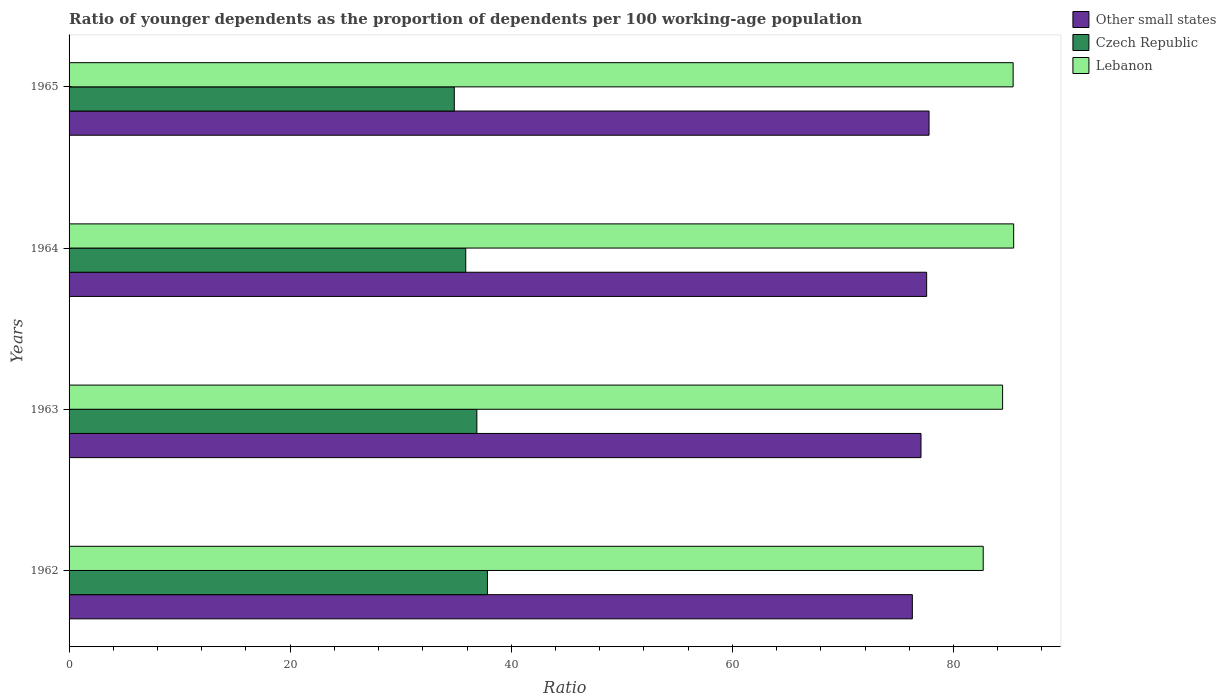Are the number of bars per tick equal to the number of legend labels?
Keep it short and to the point. Yes. How many bars are there on the 3rd tick from the bottom?
Your answer should be compact. 3. In how many cases, is the number of bars for a given year not equal to the number of legend labels?
Offer a very short reply. 0. What is the age dependency ratio(young) in Lebanon in 1965?
Provide a succinct answer. 85.39. Across all years, what is the maximum age dependency ratio(young) in Lebanon?
Provide a short and direct response. 85.44. Across all years, what is the minimum age dependency ratio(young) in Czech Republic?
Provide a short and direct response. 34.84. In which year was the age dependency ratio(young) in Other small states maximum?
Keep it short and to the point. 1965. What is the total age dependency ratio(young) in Other small states in the graph?
Ensure brevity in your answer.  308.7. What is the difference between the age dependency ratio(young) in Other small states in 1963 and that in 1964?
Ensure brevity in your answer.  -0.51. What is the difference between the age dependency ratio(young) in Czech Republic in 1962 and the age dependency ratio(young) in Other small states in 1965?
Offer a very short reply. -39.95. What is the average age dependency ratio(young) in Czech Republic per year?
Make the answer very short. 36.36. In the year 1963, what is the difference between the age dependency ratio(young) in Czech Republic and age dependency ratio(young) in Other small states?
Offer a very short reply. -40.17. What is the ratio of the age dependency ratio(young) in Czech Republic in 1962 to that in 1964?
Offer a terse response. 1.05. Is the difference between the age dependency ratio(young) in Czech Republic in 1963 and 1965 greater than the difference between the age dependency ratio(young) in Other small states in 1963 and 1965?
Your response must be concise. Yes. What is the difference between the highest and the second highest age dependency ratio(young) in Czech Republic?
Offer a terse response. 0.95. What is the difference between the highest and the lowest age dependency ratio(young) in Lebanon?
Provide a short and direct response. 2.75. Is the sum of the age dependency ratio(young) in Czech Republic in 1962 and 1964 greater than the maximum age dependency ratio(young) in Lebanon across all years?
Provide a short and direct response. No. What does the 3rd bar from the top in 1965 represents?
Provide a succinct answer. Other small states. What does the 1st bar from the bottom in 1962 represents?
Offer a very short reply. Other small states. Is it the case that in every year, the sum of the age dependency ratio(young) in Czech Republic and age dependency ratio(young) in Lebanon is greater than the age dependency ratio(young) in Other small states?
Offer a very short reply. Yes. How many bars are there?
Give a very brief answer. 12. How many years are there in the graph?
Your response must be concise. 4. What is the difference between two consecutive major ticks on the X-axis?
Provide a short and direct response. 20. Are the values on the major ticks of X-axis written in scientific E-notation?
Provide a short and direct response. No. Does the graph contain grids?
Offer a terse response. No. What is the title of the graph?
Keep it short and to the point. Ratio of younger dependents as the proportion of dependents per 100 working-age population. What is the label or title of the X-axis?
Your answer should be compact. Ratio. What is the Ratio of Other small states in 1962?
Your answer should be compact. 76.28. What is the Ratio of Czech Republic in 1962?
Provide a short and direct response. 37.84. What is the Ratio of Lebanon in 1962?
Offer a very short reply. 82.69. What is the Ratio of Other small states in 1963?
Your answer should be compact. 77.06. What is the Ratio in Czech Republic in 1963?
Provide a short and direct response. 36.89. What is the Ratio of Lebanon in 1963?
Provide a succinct answer. 84.44. What is the Ratio of Other small states in 1964?
Offer a very short reply. 77.57. What is the Ratio in Czech Republic in 1964?
Your answer should be compact. 35.88. What is the Ratio in Lebanon in 1964?
Make the answer very short. 85.44. What is the Ratio in Other small states in 1965?
Provide a short and direct response. 77.79. What is the Ratio of Czech Republic in 1965?
Make the answer very short. 34.84. What is the Ratio of Lebanon in 1965?
Ensure brevity in your answer.  85.39. Across all years, what is the maximum Ratio of Other small states?
Provide a succinct answer. 77.79. Across all years, what is the maximum Ratio of Czech Republic?
Offer a very short reply. 37.84. Across all years, what is the maximum Ratio in Lebanon?
Give a very brief answer. 85.44. Across all years, what is the minimum Ratio of Other small states?
Your answer should be very brief. 76.28. Across all years, what is the minimum Ratio of Czech Republic?
Offer a very short reply. 34.84. Across all years, what is the minimum Ratio of Lebanon?
Provide a succinct answer. 82.69. What is the total Ratio of Other small states in the graph?
Make the answer very short. 308.7. What is the total Ratio in Czech Republic in the graph?
Provide a succinct answer. 145.45. What is the total Ratio of Lebanon in the graph?
Provide a succinct answer. 337.97. What is the difference between the Ratio of Other small states in 1962 and that in 1963?
Your answer should be compact. -0.78. What is the difference between the Ratio in Czech Republic in 1962 and that in 1963?
Provide a succinct answer. 0.95. What is the difference between the Ratio of Lebanon in 1962 and that in 1963?
Give a very brief answer. -1.75. What is the difference between the Ratio in Other small states in 1962 and that in 1964?
Offer a very short reply. -1.29. What is the difference between the Ratio in Czech Republic in 1962 and that in 1964?
Give a very brief answer. 1.96. What is the difference between the Ratio of Lebanon in 1962 and that in 1964?
Provide a succinct answer. -2.75. What is the difference between the Ratio of Other small states in 1962 and that in 1965?
Ensure brevity in your answer.  -1.51. What is the difference between the Ratio in Czech Republic in 1962 and that in 1965?
Your answer should be very brief. 3. What is the difference between the Ratio in Lebanon in 1962 and that in 1965?
Provide a short and direct response. -2.71. What is the difference between the Ratio of Other small states in 1963 and that in 1964?
Your answer should be compact. -0.51. What is the difference between the Ratio in Lebanon in 1963 and that in 1964?
Your answer should be very brief. -1. What is the difference between the Ratio of Other small states in 1963 and that in 1965?
Ensure brevity in your answer.  -0.73. What is the difference between the Ratio in Czech Republic in 1963 and that in 1965?
Offer a very short reply. 2.04. What is the difference between the Ratio of Lebanon in 1963 and that in 1965?
Give a very brief answer. -0.95. What is the difference between the Ratio of Other small states in 1964 and that in 1965?
Your answer should be compact. -0.22. What is the difference between the Ratio of Czech Republic in 1964 and that in 1965?
Offer a very short reply. 1.04. What is the difference between the Ratio in Lebanon in 1964 and that in 1965?
Provide a succinct answer. 0.05. What is the difference between the Ratio in Other small states in 1962 and the Ratio in Czech Republic in 1963?
Offer a very short reply. 39.39. What is the difference between the Ratio in Other small states in 1962 and the Ratio in Lebanon in 1963?
Your answer should be compact. -8.16. What is the difference between the Ratio of Czech Republic in 1962 and the Ratio of Lebanon in 1963?
Offer a very short reply. -46.6. What is the difference between the Ratio in Other small states in 1962 and the Ratio in Czech Republic in 1964?
Offer a terse response. 40.4. What is the difference between the Ratio in Other small states in 1962 and the Ratio in Lebanon in 1964?
Make the answer very short. -9.17. What is the difference between the Ratio of Czech Republic in 1962 and the Ratio of Lebanon in 1964?
Offer a terse response. -47.6. What is the difference between the Ratio of Other small states in 1962 and the Ratio of Czech Republic in 1965?
Offer a very short reply. 41.43. What is the difference between the Ratio in Other small states in 1962 and the Ratio in Lebanon in 1965?
Provide a short and direct response. -9.12. What is the difference between the Ratio in Czech Republic in 1962 and the Ratio in Lebanon in 1965?
Ensure brevity in your answer.  -47.55. What is the difference between the Ratio in Other small states in 1963 and the Ratio in Czech Republic in 1964?
Offer a very short reply. 41.18. What is the difference between the Ratio in Other small states in 1963 and the Ratio in Lebanon in 1964?
Offer a very short reply. -8.38. What is the difference between the Ratio of Czech Republic in 1963 and the Ratio of Lebanon in 1964?
Offer a very short reply. -48.56. What is the difference between the Ratio in Other small states in 1963 and the Ratio in Czech Republic in 1965?
Provide a succinct answer. 42.22. What is the difference between the Ratio in Other small states in 1963 and the Ratio in Lebanon in 1965?
Your answer should be compact. -8.33. What is the difference between the Ratio of Czech Republic in 1963 and the Ratio of Lebanon in 1965?
Ensure brevity in your answer.  -48.51. What is the difference between the Ratio of Other small states in 1964 and the Ratio of Czech Republic in 1965?
Give a very brief answer. 42.73. What is the difference between the Ratio in Other small states in 1964 and the Ratio in Lebanon in 1965?
Your answer should be very brief. -7.82. What is the difference between the Ratio of Czech Republic in 1964 and the Ratio of Lebanon in 1965?
Your answer should be compact. -49.51. What is the average Ratio of Other small states per year?
Your response must be concise. 77.17. What is the average Ratio in Czech Republic per year?
Your response must be concise. 36.36. What is the average Ratio of Lebanon per year?
Your answer should be very brief. 84.49. In the year 1962, what is the difference between the Ratio of Other small states and Ratio of Czech Republic?
Your answer should be very brief. 38.44. In the year 1962, what is the difference between the Ratio of Other small states and Ratio of Lebanon?
Your answer should be very brief. -6.41. In the year 1962, what is the difference between the Ratio in Czech Republic and Ratio in Lebanon?
Provide a short and direct response. -44.85. In the year 1963, what is the difference between the Ratio of Other small states and Ratio of Czech Republic?
Make the answer very short. 40.17. In the year 1963, what is the difference between the Ratio of Other small states and Ratio of Lebanon?
Provide a succinct answer. -7.38. In the year 1963, what is the difference between the Ratio of Czech Republic and Ratio of Lebanon?
Keep it short and to the point. -47.55. In the year 1964, what is the difference between the Ratio in Other small states and Ratio in Czech Republic?
Your response must be concise. 41.69. In the year 1964, what is the difference between the Ratio in Other small states and Ratio in Lebanon?
Give a very brief answer. -7.87. In the year 1964, what is the difference between the Ratio of Czech Republic and Ratio of Lebanon?
Your answer should be compact. -49.56. In the year 1965, what is the difference between the Ratio in Other small states and Ratio in Czech Republic?
Ensure brevity in your answer.  42.94. In the year 1965, what is the difference between the Ratio in Other small states and Ratio in Lebanon?
Make the answer very short. -7.61. In the year 1965, what is the difference between the Ratio in Czech Republic and Ratio in Lebanon?
Keep it short and to the point. -50.55. What is the ratio of the Ratio in Other small states in 1962 to that in 1963?
Offer a terse response. 0.99. What is the ratio of the Ratio of Czech Republic in 1962 to that in 1963?
Your answer should be compact. 1.03. What is the ratio of the Ratio in Lebanon in 1962 to that in 1963?
Your answer should be compact. 0.98. What is the ratio of the Ratio in Other small states in 1962 to that in 1964?
Keep it short and to the point. 0.98. What is the ratio of the Ratio of Czech Republic in 1962 to that in 1964?
Your answer should be compact. 1.05. What is the ratio of the Ratio in Lebanon in 1962 to that in 1964?
Your answer should be very brief. 0.97. What is the ratio of the Ratio in Other small states in 1962 to that in 1965?
Make the answer very short. 0.98. What is the ratio of the Ratio in Czech Republic in 1962 to that in 1965?
Offer a terse response. 1.09. What is the ratio of the Ratio in Lebanon in 1962 to that in 1965?
Keep it short and to the point. 0.97. What is the ratio of the Ratio in Czech Republic in 1963 to that in 1964?
Offer a very short reply. 1.03. What is the ratio of the Ratio of Lebanon in 1963 to that in 1964?
Provide a short and direct response. 0.99. What is the ratio of the Ratio of Other small states in 1963 to that in 1965?
Offer a very short reply. 0.99. What is the ratio of the Ratio in Czech Republic in 1963 to that in 1965?
Offer a very short reply. 1.06. What is the ratio of the Ratio in Lebanon in 1963 to that in 1965?
Ensure brevity in your answer.  0.99. What is the ratio of the Ratio of Other small states in 1964 to that in 1965?
Provide a succinct answer. 1. What is the ratio of the Ratio in Czech Republic in 1964 to that in 1965?
Your answer should be very brief. 1.03. What is the difference between the highest and the second highest Ratio of Other small states?
Offer a terse response. 0.22. What is the difference between the highest and the second highest Ratio in Czech Republic?
Keep it short and to the point. 0.95. What is the difference between the highest and the second highest Ratio of Lebanon?
Your response must be concise. 0.05. What is the difference between the highest and the lowest Ratio in Other small states?
Keep it short and to the point. 1.51. What is the difference between the highest and the lowest Ratio of Czech Republic?
Provide a short and direct response. 3. What is the difference between the highest and the lowest Ratio of Lebanon?
Your answer should be very brief. 2.75. 